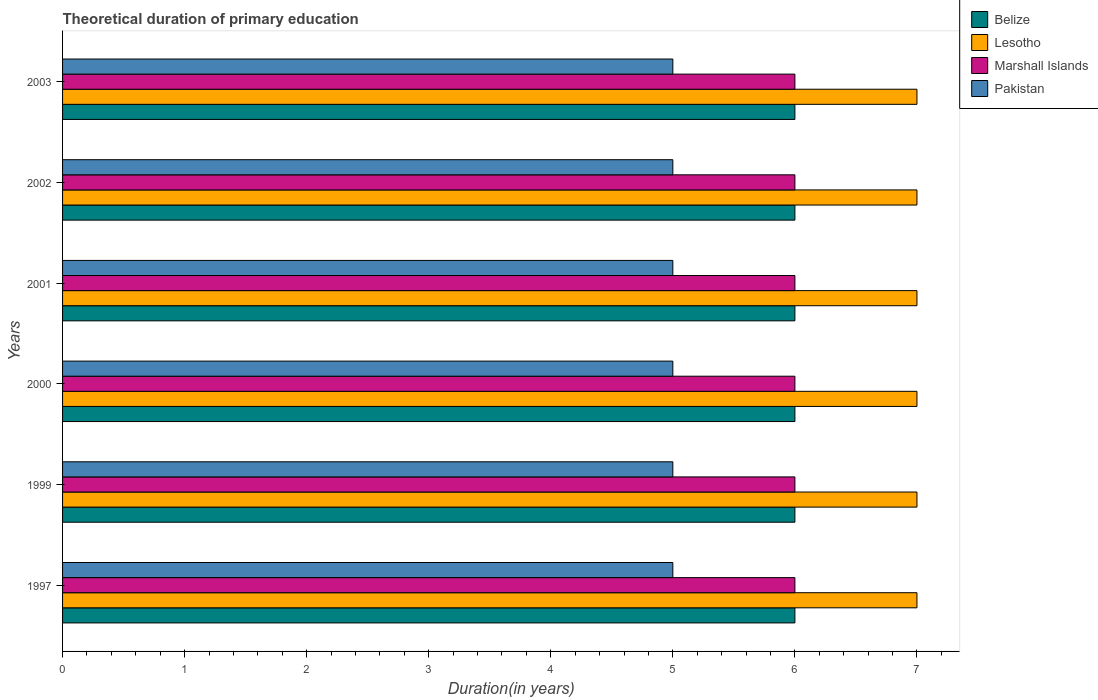How many different coloured bars are there?
Your answer should be compact. 4. How many groups of bars are there?
Your answer should be compact. 6. Are the number of bars per tick equal to the number of legend labels?
Ensure brevity in your answer.  Yes. Are the number of bars on each tick of the Y-axis equal?
Give a very brief answer. Yes. How many bars are there on the 5th tick from the top?
Your answer should be compact. 4. How many bars are there on the 2nd tick from the bottom?
Ensure brevity in your answer.  4. What is the label of the 4th group of bars from the top?
Ensure brevity in your answer.  2000. In how many cases, is the number of bars for a given year not equal to the number of legend labels?
Make the answer very short. 0. What is the total theoretical duration of primary education in Lesotho in 2002?
Your response must be concise. 7. Across all years, what is the minimum total theoretical duration of primary education in Marshall Islands?
Keep it short and to the point. 6. What is the total total theoretical duration of primary education in Belize in the graph?
Keep it short and to the point. 36. What is the average total theoretical duration of primary education in Marshall Islands per year?
Your answer should be compact. 6. In the year 2003, what is the difference between the total theoretical duration of primary education in Lesotho and total theoretical duration of primary education in Pakistan?
Keep it short and to the point. 2. What is the difference between the highest and the second highest total theoretical duration of primary education in Marshall Islands?
Make the answer very short. 0. What is the difference between the highest and the lowest total theoretical duration of primary education in Belize?
Ensure brevity in your answer.  0. Is the sum of the total theoretical duration of primary education in Marshall Islands in 1999 and 2000 greater than the maximum total theoretical duration of primary education in Belize across all years?
Provide a short and direct response. Yes. Is it the case that in every year, the sum of the total theoretical duration of primary education in Belize and total theoretical duration of primary education in Marshall Islands is greater than the sum of total theoretical duration of primary education in Lesotho and total theoretical duration of primary education in Pakistan?
Provide a short and direct response. Yes. What does the 3rd bar from the top in 1999 represents?
Offer a terse response. Lesotho. What does the 1st bar from the bottom in 2000 represents?
Your answer should be very brief. Belize. Are all the bars in the graph horizontal?
Offer a terse response. Yes. How many years are there in the graph?
Offer a terse response. 6. What is the difference between two consecutive major ticks on the X-axis?
Give a very brief answer. 1. Where does the legend appear in the graph?
Your answer should be compact. Top right. What is the title of the graph?
Keep it short and to the point. Theoretical duration of primary education. Does "India" appear as one of the legend labels in the graph?
Offer a terse response. No. What is the label or title of the X-axis?
Give a very brief answer. Duration(in years). What is the label or title of the Y-axis?
Provide a short and direct response. Years. What is the Duration(in years) of Belize in 1997?
Your answer should be very brief. 6. What is the Duration(in years) in Lesotho in 1997?
Offer a very short reply. 7. What is the Duration(in years) of Pakistan in 1999?
Make the answer very short. 5. What is the Duration(in years) in Marshall Islands in 2000?
Offer a very short reply. 6. What is the Duration(in years) in Marshall Islands in 2001?
Offer a very short reply. 6. What is the Duration(in years) in Pakistan in 2001?
Keep it short and to the point. 5. What is the Duration(in years) of Belize in 2002?
Keep it short and to the point. 6. What is the Duration(in years) of Marshall Islands in 2003?
Make the answer very short. 6. Across all years, what is the maximum Duration(in years) in Belize?
Your answer should be compact. 6. Across all years, what is the maximum Duration(in years) in Marshall Islands?
Offer a very short reply. 6. Across all years, what is the maximum Duration(in years) in Pakistan?
Offer a terse response. 5. Across all years, what is the minimum Duration(in years) in Lesotho?
Keep it short and to the point. 7. What is the total Duration(in years) of Lesotho in the graph?
Make the answer very short. 42. What is the total Duration(in years) in Marshall Islands in the graph?
Offer a terse response. 36. What is the difference between the Duration(in years) of Belize in 1997 and that in 1999?
Make the answer very short. 0. What is the difference between the Duration(in years) in Lesotho in 1997 and that in 1999?
Make the answer very short. 0. What is the difference between the Duration(in years) of Pakistan in 1997 and that in 1999?
Provide a short and direct response. 0. What is the difference between the Duration(in years) in Lesotho in 1997 and that in 2000?
Make the answer very short. 0. What is the difference between the Duration(in years) in Pakistan in 1997 and that in 2000?
Give a very brief answer. 0. What is the difference between the Duration(in years) in Lesotho in 1997 and that in 2001?
Offer a terse response. 0. What is the difference between the Duration(in years) of Marshall Islands in 1997 and that in 2001?
Offer a very short reply. 0. What is the difference between the Duration(in years) in Belize in 1997 and that in 2002?
Make the answer very short. 0. What is the difference between the Duration(in years) in Lesotho in 1997 and that in 2002?
Your answer should be very brief. 0. What is the difference between the Duration(in years) of Marshall Islands in 1997 and that in 2002?
Your response must be concise. 0. What is the difference between the Duration(in years) of Pakistan in 1997 and that in 2002?
Offer a terse response. 0. What is the difference between the Duration(in years) in Marshall Islands in 1997 and that in 2003?
Offer a very short reply. 0. What is the difference between the Duration(in years) in Lesotho in 1999 and that in 2000?
Provide a succinct answer. 0. What is the difference between the Duration(in years) in Pakistan in 1999 and that in 2000?
Keep it short and to the point. 0. What is the difference between the Duration(in years) of Marshall Islands in 1999 and that in 2001?
Offer a very short reply. 0. What is the difference between the Duration(in years) of Lesotho in 1999 and that in 2002?
Your answer should be very brief. 0. What is the difference between the Duration(in years) of Pakistan in 1999 and that in 2002?
Ensure brevity in your answer.  0. What is the difference between the Duration(in years) of Belize in 1999 and that in 2003?
Your response must be concise. 0. What is the difference between the Duration(in years) of Lesotho in 1999 and that in 2003?
Provide a succinct answer. 0. What is the difference between the Duration(in years) in Marshall Islands in 1999 and that in 2003?
Your answer should be compact. 0. What is the difference between the Duration(in years) in Marshall Islands in 2000 and that in 2001?
Offer a very short reply. 0. What is the difference between the Duration(in years) of Pakistan in 2000 and that in 2001?
Make the answer very short. 0. What is the difference between the Duration(in years) in Belize in 2000 and that in 2002?
Offer a terse response. 0. What is the difference between the Duration(in years) of Lesotho in 2000 and that in 2002?
Offer a very short reply. 0. What is the difference between the Duration(in years) of Marshall Islands in 2000 and that in 2002?
Provide a succinct answer. 0. What is the difference between the Duration(in years) of Marshall Islands in 2000 and that in 2003?
Give a very brief answer. 0. What is the difference between the Duration(in years) in Pakistan in 2000 and that in 2003?
Offer a very short reply. 0. What is the difference between the Duration(in years) in Lesotho in 2001 and that in 2002?
Offer a terse response. 0. What is the difference between the Duration(in years) of Marshall Islands in 2001 and that in 2002?
Keep it short and to the point. 0. What is the difference between the Duration(in years) in Pakistan in 2001 and that in 2002?
Make the answer very short. 0. What is the difference between the Duration(in years) of Lesotho in 2001 and that in 2003?
Keep it short and to the point. 0. What is the difference between the Duration(in years) of Marshall Islands in 2001 and that in 2003?
Provide a short and direct response. 0. What is the difference between the Duration(in years) in Lesotho in 2002 and that in 2003?
Your answer should be very brief. 0. What is the difference between the Duration(in years) in Marshall Islands in 2002 and that in 2003?
Your response must be concise. 0. What is the difference between the Duration(in years) of Belize in 1997 and the Duration(in years) of Lesotho in 1999?
Provide a short and direct response. -1. What is the difference between the Duration(in years) in Belize in 1997 and the Duration(in years) in Marshall Islands in 1999?
Provide a short and direct response. 0. What is the difference between the Duration(in years) of Belize in 1997 and the Duration(in years) of Pakistan in 1999?
Your response must be concise. 1. What is the difference between the Duration(in years) in Lesotho in 1997 and the Duration(in years) in Marshall Islands in 1999?
Ensure brevity in your answer.  1. What is the difference between the Duration(in years) in Lesotho in 1997 and the Duration(in years) in Pakistan in 1999?
Your response must be concise. 2. What is the difference between the Duration(in years) in Lesotho in 1997 and the Duration(in years) in Marshall Islands in 2000?
Provide a succinct answer. 1. What is the difference between the Duration(in years) in Lesotho in 1997 and the Duration(in years) in Pakistan in 2000?
Provide a succinct answer. 2. What is the difference between the Duration(in years) in Belize in 1997 and the Duration(in years) in Lesotho in 2001?
Your answer should be compact. -1. What is the difference between the Duration(in years) in Belize in 1997 and the Duration(in years) in Marshall Islands in 2001?
Your response must be concise. 0. What is the difference between the Duration(in years) of Belize in 1997 and the Duration(in years) of Pakistan in 2002?
Make the answer very short. 1. What is the difference between the Duration(in years) in Lesotho in 1997 and the Duration(in years) in Marshall Islands in 2002?
Offer a very short reply. 1. What is the difference between the Duration(in years) in Belize in 1997 and the Duration(in years) in Lesotho in 2003?
Your answer should be compact. -1. What is the difference between the Duration(in years) of Lesotho in 1997 and the Duration(in years) of Pakistan in 2003?
Keep it short and to the point. 2. What is the difference between the Duration(in years) of Belize in 1999 and the Duration(in years) of Marshall Islands in 2000?
Give a very brief answer. 0. What is the difference between the Duration(in years) of Lesotho in 1999 and the Duration(in years) of Marshall Islands in 2000?
Your response must be concise. 1. What is the difference between the Duration(in years) of Marshall Islands in 1999 and the Duration(in years) of Pakistan in 2000?
Provide a succinct answer. 1. What is the difference between the Duration(in years) in Belize in 1999 and the Duration(in years) in Marshall Islands in 2001?
Keep it short and to the point. 0. What is the difference between the Duration(in years) of Belize in 1999 and the Duration(in years) of Pakistan in 2001?
Provide a succinct answer. 1. What is the difference between the Duration(in years) in Lesotho in 1999 and the Duration(in years) in Marshall Islands in 2001?
Provide a succinct answer. 1. What is the difference between the Duration(in years) of Belize in 1999 and the Duration(in years) of Pakistan in 2002?
Keep it short and to the point. 1. What is the difference between the Duration(in years) in Lesotho in 1999 and the Duration(in years) in Marshall Islands in 2002?
Provide a short and direct response. 1. What is the difference between the Duration(in years) in Lesotho in 1999 and the Duration(in years) in Pakistan in 2002?
Your response must be concise. 2. What is the difference between the Duration(in years) in Marshall Islands in 1999 and the Duration(in years) in Pakistan in 2002?
Your response must be concise. 1. What is the difference between the Duration(in years) in Belize in 1999 and the Duration(in years) in Lesotho in 2003?
Provide a short and direct response. -1. What is the difference between the Duration(in years) of Belize in 1999 and the Duration(in years) of Marshall Islands in 2003?
Make the answer very short. 0. What is the difference between the Duration(in years) of Lesotho in 1999 and the Duration(in years) of Pakistan in 2003?
Your answer should be very brief. 2. What is the difference between the Duration(in years) in Belize in 2000 and the Duration(in years) in Lesotho in 2001?
Provide a succinct answer. -1. What is the difference between the Duration(in years) in Belize in 2000 and the Duration(in years) in Marshall Islands in 2001?
Provide a short and direct response. 0. What is the difference between the Duration(in years) of Belize in 2000 and the Duration(in years) of Lesotho in 2002?
Offer a very short reply. -1. What is the difference between the Duration(in years) of Belize in 2000 and the Duration(in years) of Pakistan in 2002?
Provide a succinct answer. 1. What is the difference between the Duration(in years) of Lesotho in 2000 and the Duration(in years) of Pakistan in 2002?
Your answer should be very brief. 2. What is the difference between the Duration(in years) in Lesotho in 2000 and the Duration(in years) in Pakistan in 2003?
Offer a very short reply. 2. What is the difference between the Duration(in years) of Belize in 2001 and the Duration(in years) of Lesotho in 2002?
Ensure brevity in your answer.  -1. What is the difference between the Duration(in years) in Belize in 2001 and the Duration(in years) in Marshall Islands in 2002?
Provide a succinct answer. 0. What is the difference between the Duration(in years) of Belize in 2002 and the Duration(in years) of Lesotho in 2003?
Offer a terse response. -1. What is the difference between the Duration(in years) in Marshall Islands in 2002 and the Duration(in years) in Pakistan in 2003?
Give a very brief answer. 1. In the year 1997, what is the difference between the Duration(in years) of Belize and Duration(in years) of Marshall Islands?
Your answer should be compact. 0. In the year 1999, what is the difference between the Duration(in years) of Belize and Duration(in years) of Lesotho?
Offer a terse response. -1. In the year 2000, what is the difference between the Duration(in years) in Belize and Duration(in years) in Marshall Islands?
Offer a very short reply. 0. In the year 2000, what is the difference between the Duration(in years) of Belize and Duration(in years) of Pakistan?
Your answer should be very brief. 1. In the year 2000, what is the difference between the Duration(in years) of Lesotho and Duration(in years) of Marshall Islands?
Offer a very short reply. 1. In the year 2000, what is the difference between the Duration(in years) in Marshall Islands and Duration(in years) in Pakistan?
Keep it short and to the point. 1. In the year 2001, what is the difference between the Duration(in years) of Belize and Duration(in years) of Pakistan?
Provide a short and direct response. 1. In the year 2001, what is the difference between the Duration(in years) of Lesotho and Duration(in years) of Marshall Islands?
Provide a short and direct response. 1. In the year 2001, what is the difference between the Duration(in years) of Marshall Islands and Duration(in years) of Pakistan?
Give a very brief answer. 1. In the year 2002, what is the difference between the Duration(in years) in Lesotho and Duration(in years) in Pakistan?
Give a very brief answer. 2. In the year 2003, what is the difference between the Duration(in years) of Belize and Duration(in years) of Marshall Islands?
Offer a very short reply. 0. In the year 2003, what is the difference between the Duration(in years) of Lesotho and Duration(in years) of Pakistan?
Your response must be concise. 2. What is the ratio of the Duration(in years) of Belize in 1997 to that in 1999?
Ensure brevity in your answer.  1. What is the ratio of the Duration(in years) of Marshall Islands in 1997 to that in 2000?
Offer a terse response. 1. What is the ratio of the Duration(in years) in Pakistan in 1997 to that in 2000?
Provide a succinct answer. 1. What is the ratio of the Duration(in years) of Lesotho in 1997 to that in 2001?
Provide a short and direct response. 1. What is the ratio of the Duration(in years) of Pakistan in 1997 to that in 2001?
Offer a very short reply. 1. What is the ratio of the Duration(in years) in Lesotho in 1997 to that in 2002?
Your answer should be compact. 1. What is the ratio of the Duration(in years) in Marshall Islands in 1997 to that in 2002?
Offer a terse response. 1. What is the ratio of the Duration(in years) in Pakistan in 1997 to that in 2002?
Your response must be concise. 1. What is the ratio of the Duration(in years) in Belize in 1997 to that in 2003?
Your answer should be very brief. 1. What is the ratio of the Duration(in years) in Marshall Islands in 1997 to that in 2003?
Provide a short and direct response. 1. What is the ratio of the Duration(in years) of Pakistan in 1997 to that in 2003?
Offer a very short reply. 1. What is the ratio of the Duration(in years) of Belize in 1999 to that in 2001?
Your answer should be compact. 1. What is the ratio of the Duration(in years) of Lesotho in 1999 to that in 2002?
Provide a short and direct response. 1. What is the ratio of the Duration(in years) in Marshall Islands in 1999 to that in 2002?
Your response must be concise. 1. What is the ratio of the Duration(in years) in Lesotho in 1999 to that in 2003?
Ensure brevity in your answer.  1. What is the ratio of the Duration(in years) of Marshall Islands in 1999 to that in 2003?
Provide a short and direct response. 1. What is the ratio of the Duration(in years) in Marshall Islands in 2000 to that in 2002?
Offer a very short reply. 1. What is the ratio of the Duration(in years) of Pakistan in 2000 to that in 2002?
Ensure brevity in your answer.  1. What is the ratio of the Duration(in years) of Belize in 2000 to that in 2003?
Provide a short and direct response. 1. What is the ratio of the Duration(in years) of Lesotho in 2000 to that in 2003?
Make the answer very short. 1. What is the ratio of the Duration(in years) of Pakistan in 2000 to that in 2003?
Your response must be concise. 1. What is the ratio of the Duration(in years) of Belize in 2001 to that in 2002?
Your answer should be compact. 1. What is the ratio of the Duration(in years) in Lesotho in 2001 to that in 2002?
Give a very brief answer. 1. What is the ratio of the Duration(in years) in Marshall Islands in 2001 to that in 2002?
Give a very brief answer. 1. What is the ratio of the Duration(in years) in Pakistan in 2001 to that in 2002?
Offer a very short reply. 1. What is the ratio of the Duration(in years) in Belize in 2001 to that in 2003?
Provide a succinct answer. 1. What is the ratio of the Duration(in years) of Lesotho in 2001 to that in 2003?
Give a very brief answer. 1. What is the ratio of the Duration(in years) in Marshall Islands in 2001 to that in 2003?
Ensure brevity in your answer.  1. What is the ratio of the Duration(in years) of Belize in 2002 to that in 2003?
Ensure brevity in your answer.  1. What is the ratio of the Duration(in years) in Lesotho in 2002 to that in 2003?
Ensure brevity in your answer.  1. What is the difference between the highest and the second highest Duration(in years) of Belize?
Keep it short and to the point. 0. What is the difference between the highest and the second highest Duration(in years) in Lesotho?
Your answer should be very brief. 0. What is the difference between the highest and the lowest Duration(in years) in Belize?
Provide a short and direct response. 0. What is the difference between the highest and the lowest Duration(in years) in Pakistan?
Ensure brevity in your answer.  0. 